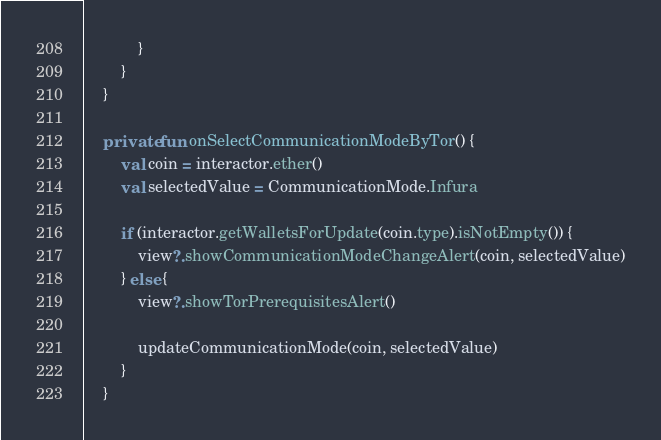Convert code to text. <code><loc_0><loc_0><loc_500><loc_500><_Kotlin_>            }
        }
    }

    private fun onSelectCommunicationModeByTor() {
        val coin = interactor.ether()
        val selectedValue = CommunicationMode.Infura

        if (interactor.getWalletsForUpdate(coin.type).isNotEmpty()) {
            view?.showCommunicationModeChangeAlert(coin, selectedValue)
        } else {
            view?.showTorPrerequisitesAlert()

            updateCommunicationMode(coin, selectedValue)
        }
    }
</code> 